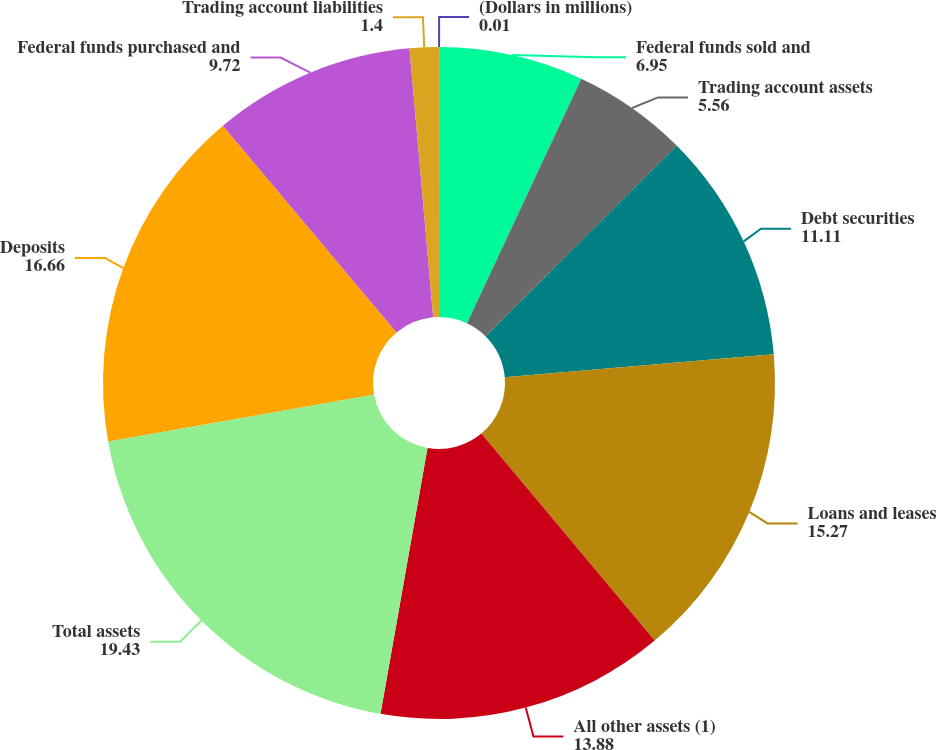<chart> <loc_0><loc_0><loc_500><loc_500><pie_chart><fcel>(Dollars in millions)<fcel>Federal funds sold and<fcel>Trading account assets<fcel>Debt securities<fcel>Loans and leases<fcel>All other assets (1)<fcel>Total assets<fcel>Deposits<fcel>Federal funds purchased and<fcel>Trading account liabilities<nl><fcel>0.01%<fcel>6.95%<fcel>5.56%<fcel>11.11%<fcel>15.27%<fcel>13.88%<fcel>19.43%<fcel>16.66%<fcel>9.72%<fcel>1.4%<nl></chart> 